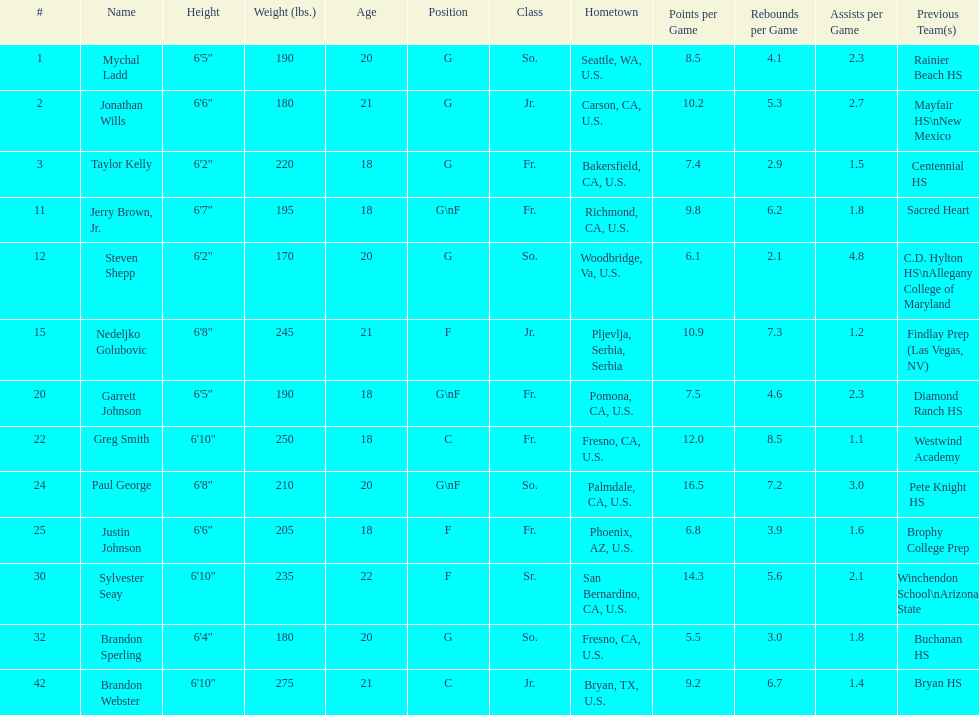I'm looking to parse the entire table for insights. Could you assist me with that? {'header': ['#', 'Name', 'Height', 'Weight (lbs.)', 'Age', 'Position', 'Class', 'Hometown', 'Points per Game', 'Rebounds per Game', 'Assists per Game', 'Previous Team(s)'], 'rows': [['1', 'Mychal Ladd', '6\'5"', '190', '20', 'G', 'So.', 'Seattle, WA, U.S.', '8.5', '4.1', '2.3', 'Rainier Beach HS'], ['2', 'Jonathan Wills', '6\'6"', '180', '21', 'G', 'Jr.', 'Carson, CA, U.S.', '10.2', '5.3', '2.7', 'Mayfair HS\\nNew Mexico'], ['3', 'Taylor Kelly', '6\'2"', '220', '18', 'G', 'Fr.', 'Bakersfield, CA, U.S.', '7.4', '2.9', '1.5', 'Centennial HS'], ['11', 'Jerry Brown, Jr.', '6\'7"', '195', '18', 'G\\nF', 'Fr.', 'Richmond, CA, U.S.', '9.8', '6.2', '1.8', 'Sacred Heart'], ['12', 'Steven Shepp', '6\'2"', '170', '20', 'G', 'So.', 'Woodbridge, Va, U.S.', '6.1', '2.1', '4.8', 'C.D. Hylton HS\\nAllegany College of Maryland'], ['15', 'Nedeljko Golubovic', '6\'8"', '245', '21', 'F', 'Jr.', 'Pljevlja, Serbia, Serbia', '10.9', '7.3', '1.2', 'Findlay Prep (Las Vegas, NV)'], ['20', 'Garrett Johnson', '6\'5"', '190', '18', 'G\\nF', 'Fr.', 'Pomona, CA, U.S.', '7.5', '4.6', '2.3', 'Diamond Ranch HS'], ['22', 'Greg Smith', '6\'10"', '250', '18', 'C', 'Fr.', 'Fresno, CA, U.S.', '12.0', '8.5', '1.1', 'Westwind Academy'], ['24', 'Paul George', '6\'8"', '210', '20', 'G\\nF', 'So.', 'Palmdale, CA, U.S.', '16.5', '7.2', '3.0', 'Pete Knight HS'], ['25', 'Justin Johnson', '6\'6"', '205', '18', 'F', 'Fr.', 'Phoenix, AZ, U.S.', '6.8', '3.9', '1.6', 'Brophy College Prep'], ['30', 'Sylvester Seay', '6\'10"', '235', '22', 'F', 'Sr.', 'San Bernardino, CA, U.S.', '14.3', '5.6', '2.1', 'Winchendon School\\nArizona State'], ['32', 'Brandon Sperling', '6\'4"', '180', '20', 'G', 'So.', 'Fresno, CA, U.S.', '5.5', '3.0', '1.8', 'Buchanan HS'], ['42', 'Brandon Webster', '6\'10"', '275', '21', 'C', 'Jr.', 'Bryan, TX, U.S.', '9.2', '6.7', '1.4', 'Bryan HS']]} Who weighs the most on the team? Brandon Webster. 